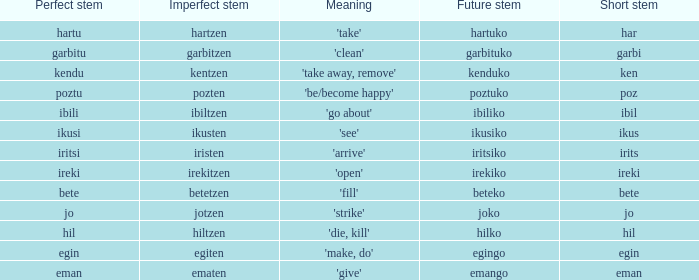Name the perfect stem for jo 1.0. 